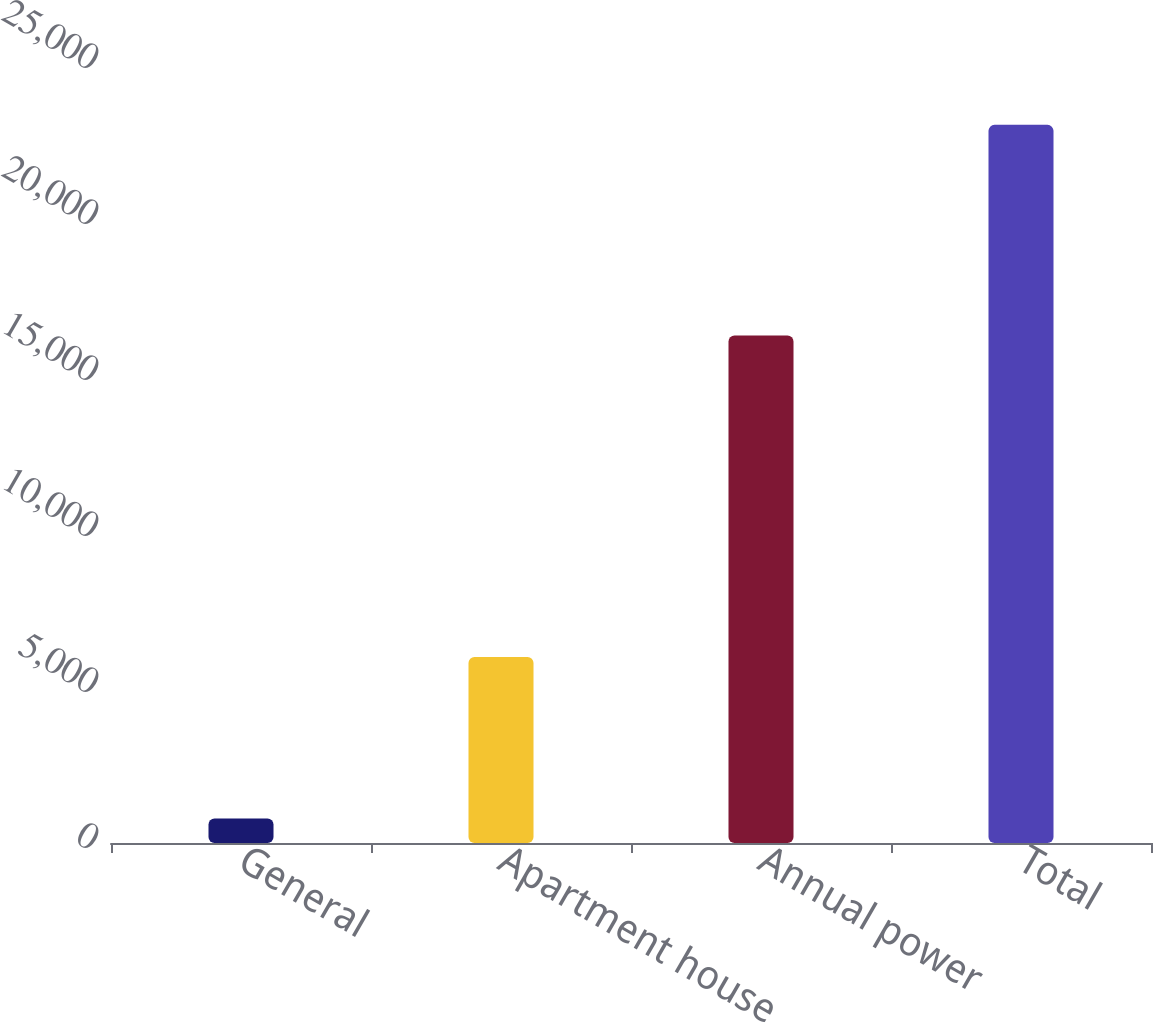Convert chart. <chart><loc_0><loc_0><loc_500><loc_500><bar_chart><fcel>General<fcel>Apartment house<fcel>Annual power<fcel>Total<nl><fcel>786<fcel>5962<fcel>16269<fcel>23017<nl></chart> 